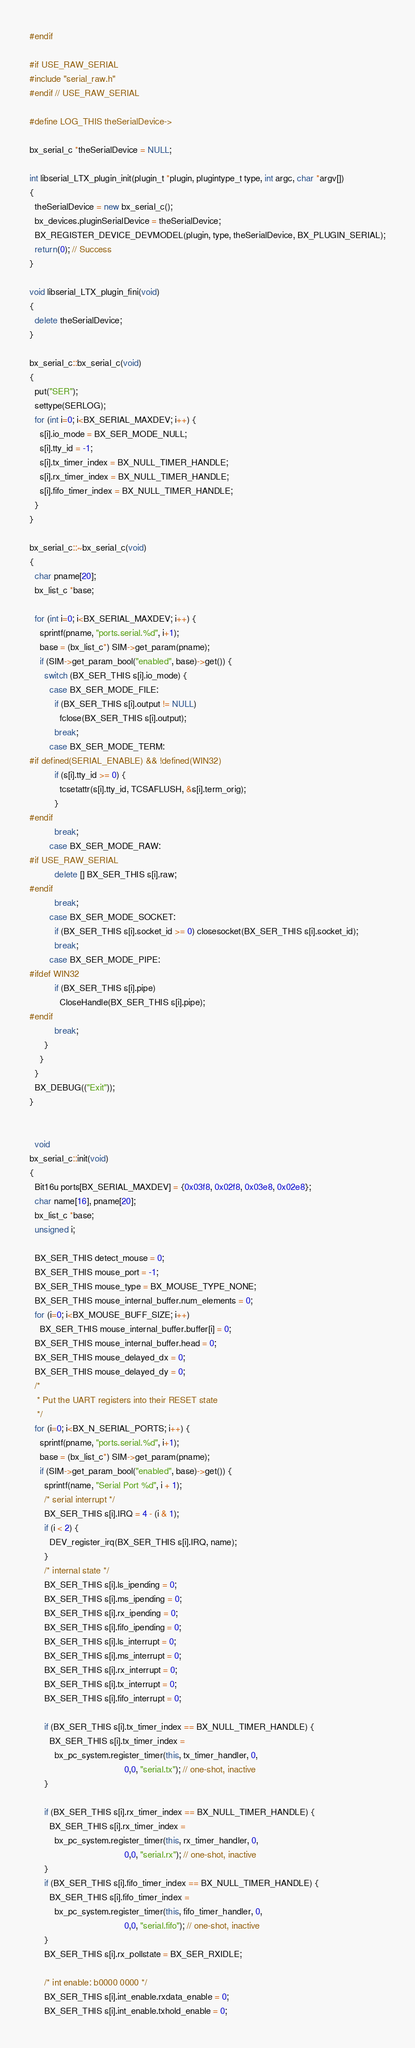Convert code to text. <code><loc_0><loc_0><loc_500><loc_500><_C++_>#endif

#if USE_RAW_SERIAL
#include "serial_raw.h"
#endif // USE_RAW_SERIAL

#define LOG_THIS theSerialDevice->

bx_serial_c *theSerialDevice = NULL;

int libserial_LTX_plugin_init(plugin_t *plugin, plugintype_t type, int argc, char *argv[])
{
  theSerialDevice = new bx_serial_c();
  bx_devices.pluginSerialDevice = theSerialDevice;
  BX_REGISTER_DEVICE_DEVMODEL(plugin, type, theSerialDevice, BX_PLUGIN_SERIAL);
  return(0); // Success
}

void libserial_LTX_plugin_fini(void)
{
  delete theSerialDevice;
}

bx_serial_c::bx_serial_c(void)
{
  put("SER");
  settype(SERLOG);
  for (int i=0; i<BX_SERIAL_MAXDEV; i++) {
    s[i].io_mode = BX_SER_MODE_NULL;
    s[i].tty_id = -1;
    s[i].tx_timer_index = BX_NULL_TIMER_HANDLE;
    s[i].rx_timer_index = BX_NULL_TIMER_HANDLE;
    s[i].fifo_timer_index = BX_NULL_TIMER_HANDLE;
  }
}

bx_serial_c::~bx_serial_c(void)
{
  char pname[20];
  bx_list_c *base;

  for (int i=0; i<BX_SERIAL_MAXDEV; i++) {
    sprintf(pname, "ports.serial.%d", i+1);
    base = (bx_list_c*) SIM->get_param(pname);
    if (SIM->get_param_bool("enabled", base)->get()) {
      switch (BX_SER_THIS s[i].io_mode) {
        case BX_SER_MODE_FILE:
          if (BX_SER_THIS s[i].output != NULL)
            fclose(BX_SER_THIS s[i].output);
          break;
        case BX_SER_MODE_TERM:
#if defined(SERIAL_ENABLE) && !defined(WIN32)
          if (s[i].tty_id >= 0) {
            tcsetattr(s[i].tty_id, TCSAFLUSH, &s[i].term_orig);
          }
#endif
          break;
        case BX_SER_MODE_RAW:
#if USE_RAW_SERIAL
          delete [] BX_SER_THIS s[i].raw;
#endif
          break;
        case BX_SER_MODE_SOCKET:
          if (BX_SER_THIS s[i].socket_id >= 0) closesocket(BX_SER_THIS s[i].socket_id);
          break;
        case BX_SER_MODE_PIPE:
#ifdef WIN32
          if (BX_SER_THIS s[i].pipe)
            CloseHandle(BX_SER_THIS s[i].pipe);
#endif
          break;
      }
    }
  }
  BX_DEBUG(("Exit"));
}


  void
bx_serial_c::init(void)
{
  Bit16u ports[BX_SERIAL_MAXDEV] = {0x03f8, 0x02f8, 0x03e8, 0x02e8};
  char name[16], pname[20];
  bx_list_c *base;
  unsigned i;

  BX_SER_THIS detect_mouse = 0;
  BX_SER_THIS mouse_port = -1;
  BX_SER_THIS mouse_type = BX_MOUSE_TYPE_NONE;
  BX_SER_THIS mouse_internal_buffer.num_elements = 0;
  for (i=0; i<BX_MOUSE_BUFF_SIZE; i++)
    BX_SER_THIS mouse_internal_buffer.buffer[i] = 0;
  BX_SER_THIS mouse_internal_buffer.head = 0;
  BX_SER_THIS mouse_delayed_dx = 0;
  BX_SER_THIS mouse_delayed_dy = 0;
  /*
   * Put the UART registers into their RESET state
   */
  for (i=0; i<BX_N_SERIAL_PORTS; i++) {
    sprintf(pname, "ports.serial.%d", i+1);
    base = (bx_list_c*) SIM->get_param(pname);
    if (SIM->get_param_bool("enabled", base)->get()) {
      sprintf(name, "Serial Port %d", i + 1);
      /* serial interrupt */
      BX_SER_THIS s[i].IRQ = 4 - (i & 1);
      if (i < 2) {
        DEV_register_irq(BX_SER_THIS s[i].IRQ, name);
      }
      /* internal state */
      BX_SER_THIS s[i].ls_ipending = 0;
      BX_SER_THIS s[i].ms_ipending = 0;
      BX_SER_THIS s[i].rx_ipending = 0;
      BX_SER_THIS s[i].fifo_ipending = 0;
      BX_SER_THIS s[i].ls_interrupt = 0;
      BX_SER_THIS s[i].ms_interrupt = 0;
      BX_SER_THIS s[i].rx_interrupt = 0;
      BX_SER_THIS s[i].tx_interrupt = 0;
      BX_SER_THIS s[i].fifo_interrupt = 0;

      if (BX_SER_THIS s[i].tx_timer_index == BX_NULL_TIMER_HANDLE) {
        BX_SER_THIS s[i].tx_timer_index =
          bx_pc_system.register_timer(this, tx_timer_handler, 0,
                                      0,0, "serial.tx"); // one-shot, inactive
      }

      if (BX_SER_THIS s[i].rx_timer_index == BX_NULL_TIMER_HANDLE) {
        BX_SER_THIS s[i].rx_timer_index =
          bx_pc_system.register_timer(this, rx_timer_handler, 0,
                                      0,0, "serial.rx"); // one-shot, inactive
      }
      if (BX_SER_THIS s[i].fifo_timer_index == BX_NULL_TIMER_HANDLE) {
        BX_SER_THIS s[i].fifo_timer_index =
          bx_pc_system.register_timer(this, fifo_timer_handler, 0,
                                      0,0, "serial.fifo"); // one-shot, inactive
      }
      BX_SER_THIS s[i].rx_pollstate = BX_SER_RXIDLE;

      /* int enable: b0000 0000 */
      BX_SER_THIS s[i].int_enable.rxdata_enable = 0;
      BX_SER_THIS s[i].int_enable.txhold_enable = 0;</code> 